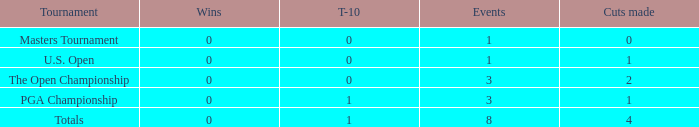For more than 3 events in the PGA Championship, what is the fewest number of wins? None. 